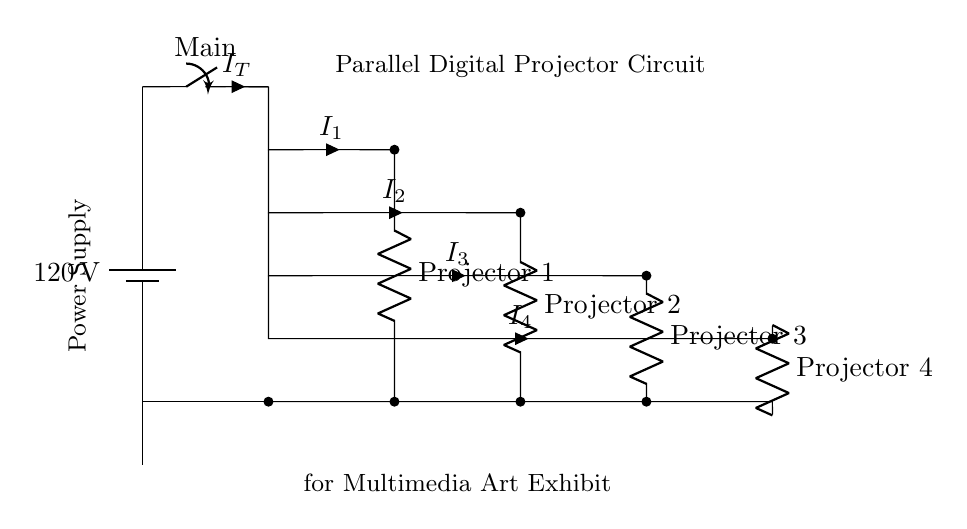What is the voltage supplied to the circuit? The voltage supplied is 120 volts, indicated next to the battery in the diagram.
Answer: 120 volts What are the components connected in parallel? The components connected in parallel are Projector 1, Projector 2, Projector 3, and Projector 4. Each is represented by a resistor symbol in individual branches.
Answer: Projector 1, Projector 2, Projector 3, Projector 4 What is the total current labeled in the circuit? The total current is indicated as I subscript T, which shows the aggregate current flowing from the main switch to the parallel branches.
Answer: I subscript T Which projector branch carries the largest potential drop? In a parallel circuit, the potential drop across all branches is the same; therefore, all projector branches have the same voltage drop of 120 volts.
Answer: 120 volts How many current paths are there in this circuit? There are four distinct current paths, as shown by the branches leading to each projector.
Answer: Four If one projector fails, what happens to the others? In a parallel circuit, if one branch fails, the other branches remain functional because they have separate paths for the current.
Answer: They remain functional What do the current values labeled I1, I2, I3, and I4 represent? The currents labeled I1, I2, I3, and I4 represent the individual currents flowing through Projector 1, Projector 2, Projector 3, and Projector 4, respectively, in the circuit.
Answer: Individual currents through each projector 